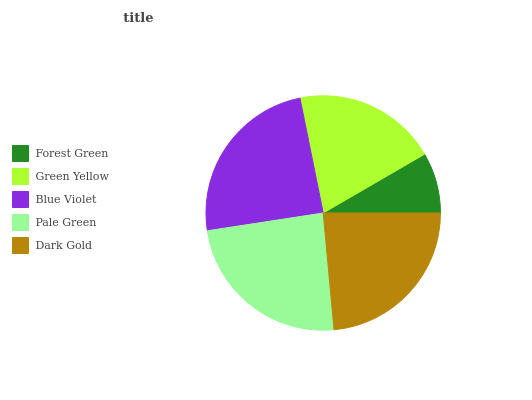Is Forest Green the minimum?
Answer yes or no. Yes. Is Blue Violet the maximum?
Answer yes or no. Yes. Is Green Yellow the minimum?
Answer yes or no. No. Is Green Yellow the maximum?
Answer yes or no. No. Is Green Yellow greater than Forest Green?
Answer yes or no. Yes. Is Forest Green less than Green Yellow?
Answer yes or no. Yes. Is Forest Green greater than Green Yellow?
Answer yes or no. No. Is Green Yellow less than Forest Green?
Answer yes or no. No. Is Dark Gold the high median?
Answer yes or no. Yes. Is Dark Gold the low median?
Answer yes or no. Yes. Is Green Yellow the high median?
Answer yes or no. No. Is Pale Green the low median?
Answer yes or no. No. 